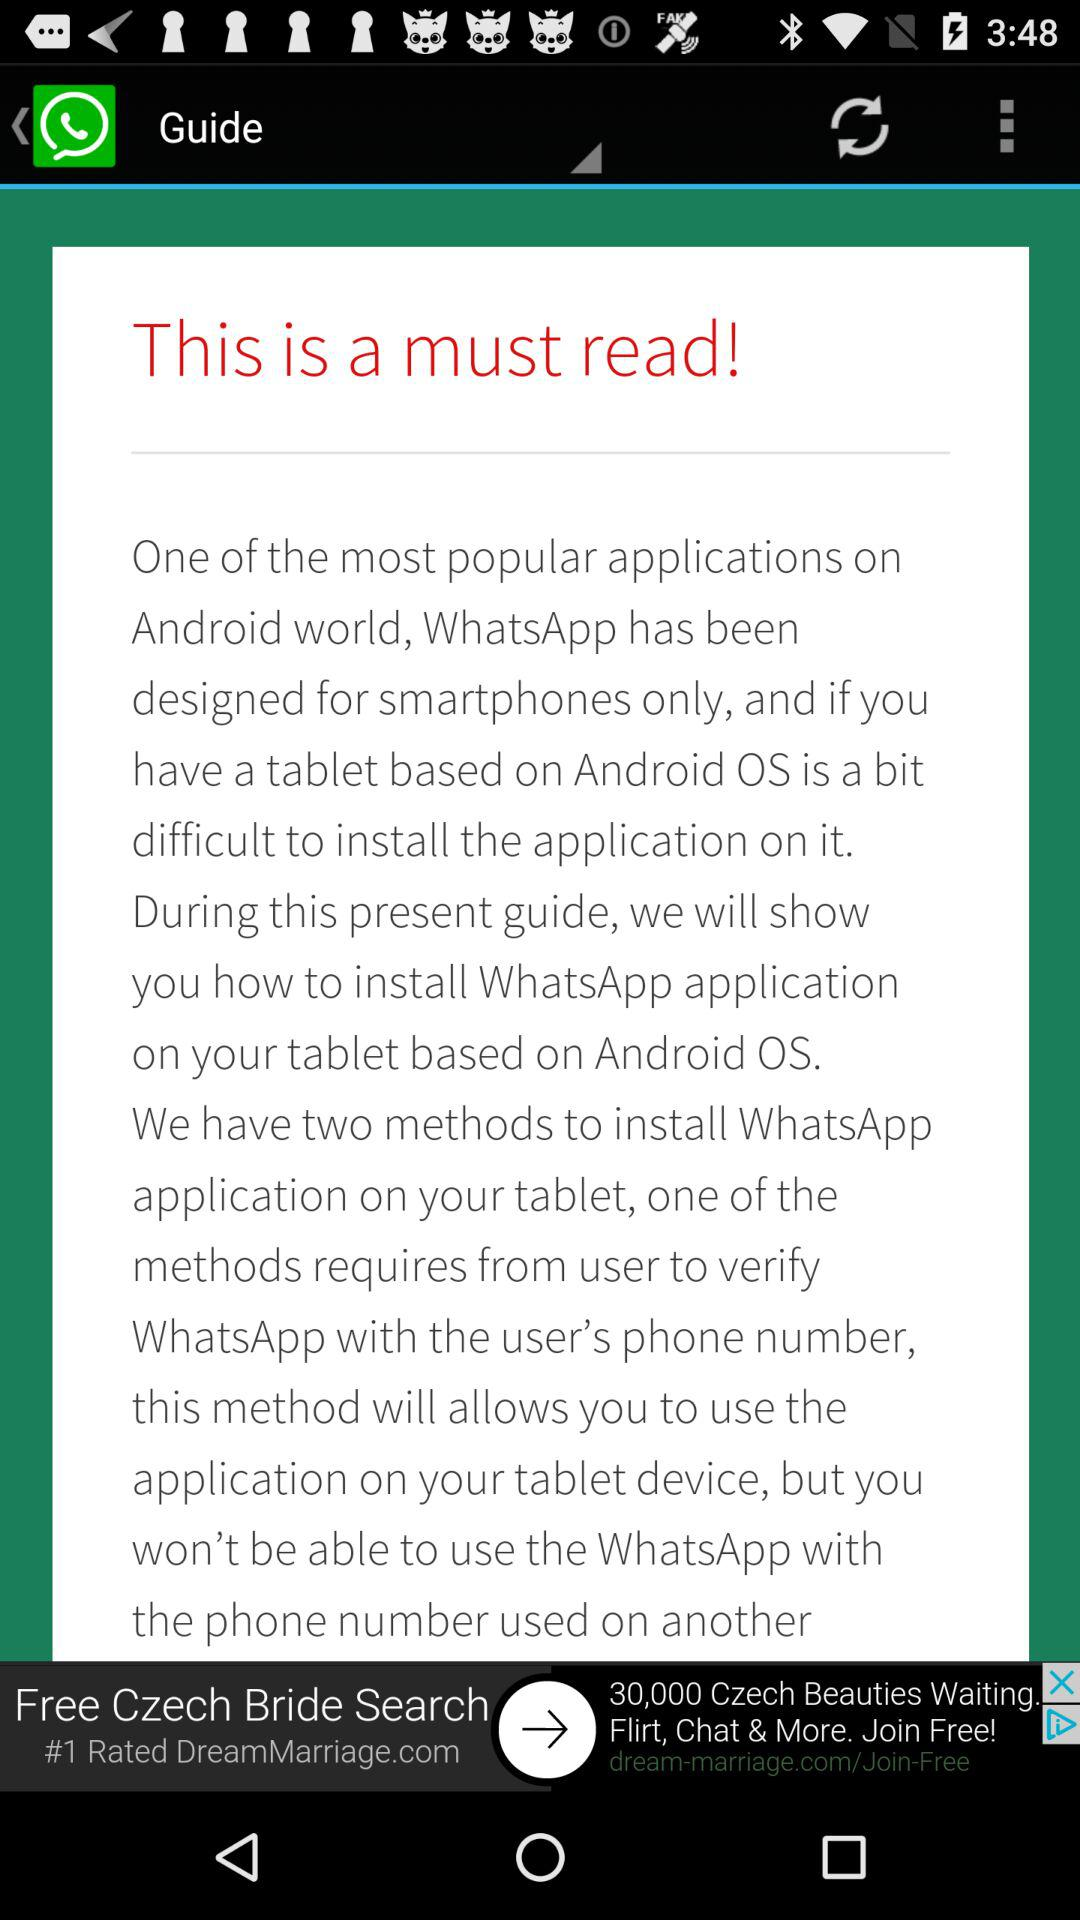What is the most popular application in the Android world? The most popular application in the Android world is "WhatsApp". 